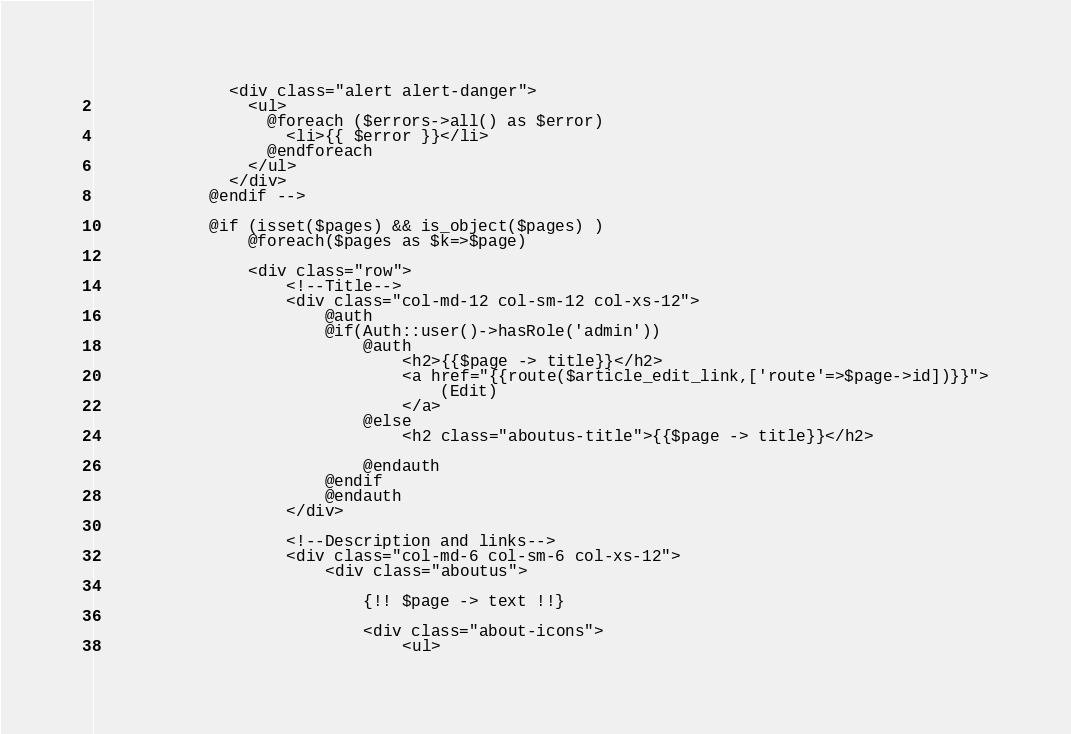<code> <loc_0><loc_0><loc_500><loc_500><_PHP_>              <div class="alert alert-danger">
                <ul>
                  @foreach ($errors->all() as $error)
                    <li>{{ $error }}</li>
                  @endforeach
                </ul>
              </div>
            @endif -->
                
            @if (isset($pages) && is_object($pages) )
				@foreach($pages as $k=>$page)
    						
                <div class="row">
                    <!--Title-->
                    <div class="col-md-12 col-sm-12 col-xs-12">
                        @auth
                        @if(Auth::user()->hasRole('admin'))
		                    @auth
		                        <h2>{{$page -> title}}</h2>
		                        <a href="{{route($article_edit_link,['route'=>$page->id])}}">
                                    (Edit)
                                </a>
		                    @else
                                <h2 class="aboutus-title">{{$page -> title}}</h2>

		                    @endauth
		                @endif
                        @endauth
                    </div>
                    
                    <!--Description and links-->
                    <div class="col-md-6 col-sm-6 col-xs-12">
                        <div class="aboutus">
                            
    						{!! $page -> text !!}
    
        			        <div class="about-icons"> 
                                <ul>            </code> 